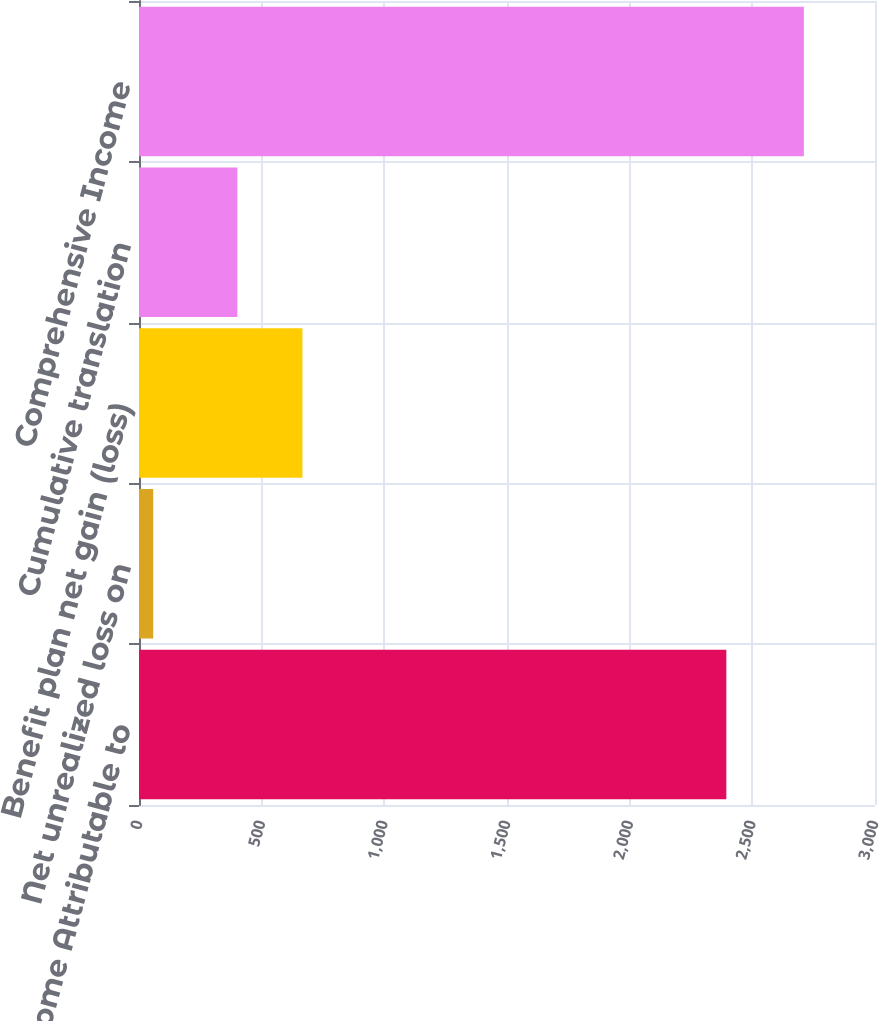Convert chart. <chart><loc_0><loc_0><loc_500><loc_500><bar_chart><fcel>Net Income Attributable to<fcel>Net unrealized loss on<fcel>Benefit plan net gain (loss)<fcel>Cumulative translation<fcel>Comprehensive Income<nl><fcel>2394<fcel>58<fcel>666.2<fcel>401<fcel>2710<nl></chart> 